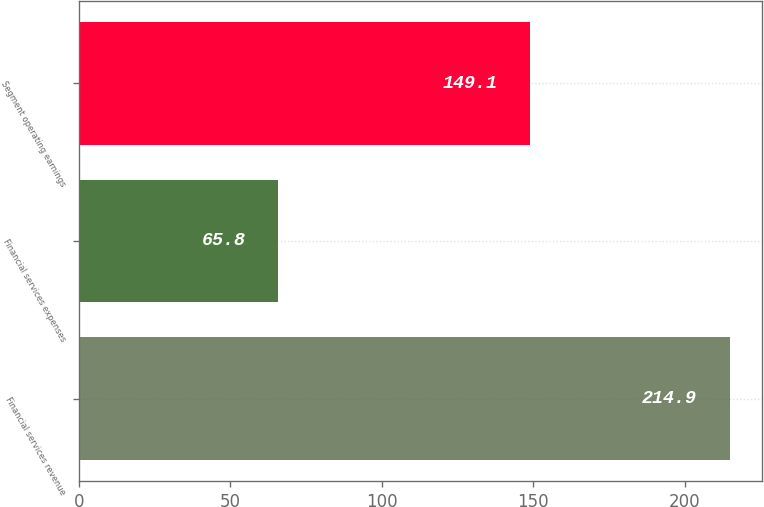Convert chart to OTSL. <chart><loc_0><loc_0><loc_500><loc_500><bar_chart><fcel>Financial services revenue<fcel>Financial services expenses<fcel>Segment operating earnings<nl><fcel>214.9<fcel>65.8<fcel>149.1<nl></chart> 